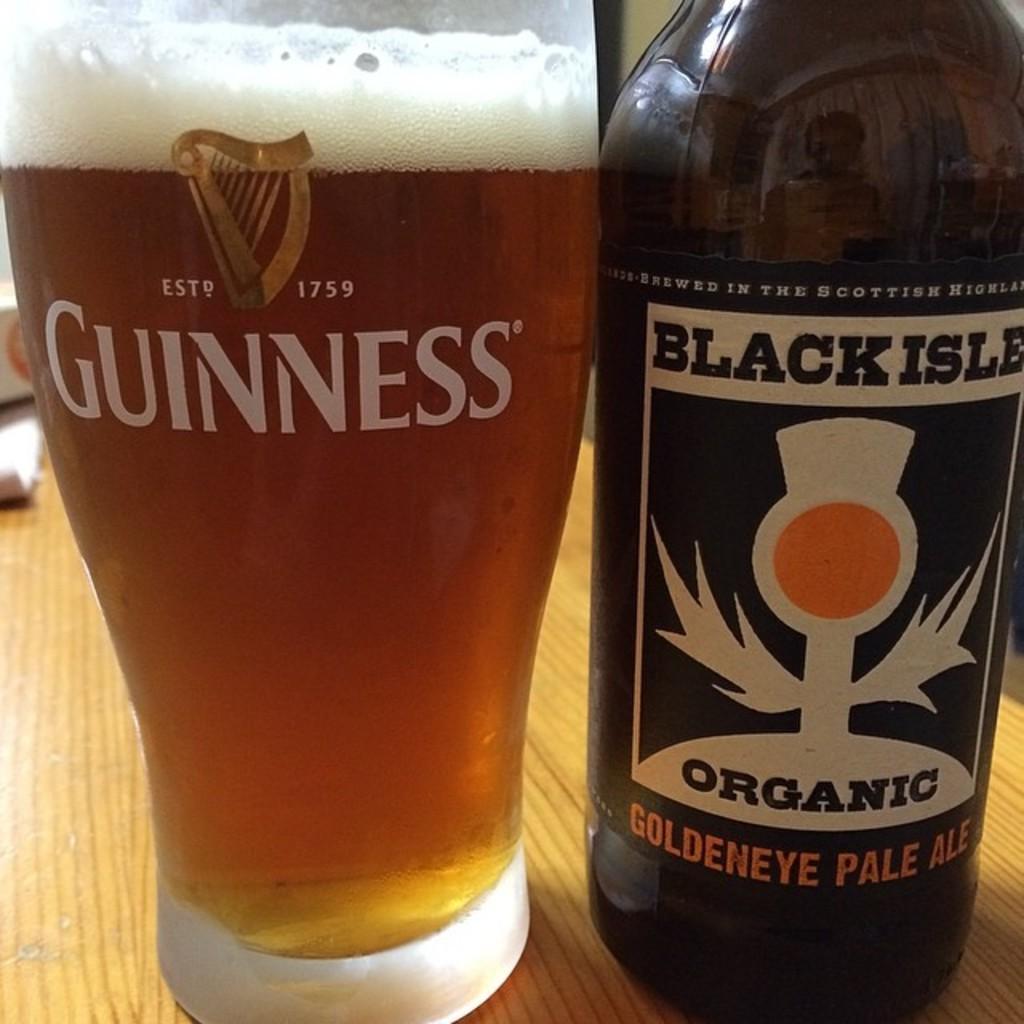Can you describe this image briefly? In the center of the image there is a table. On the table we can see box, paper, bottle, a glass which contains beer. 